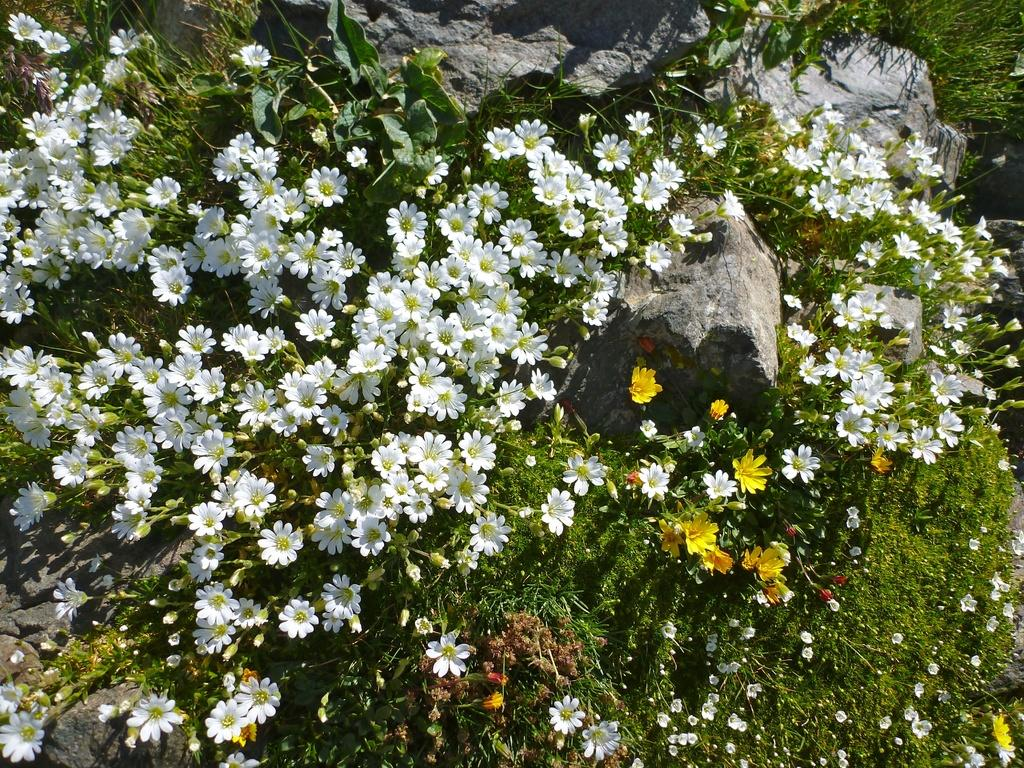What type of living organisms can be seen in the image? Plants and flowers are visible in the image. What stage of growth can be observed in the plants? There are buds in the image, indicating that some of the plants are in the early stages of growth. What other elements are present in the image? Rocks can be seen in the image. What type of voice can be heard coming from the plants in the image? There is no voice present in the image, as plants do not have the ability to produce or communicate through sound. 